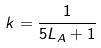<formula> <loc_0><loc_0><loc_500><loc_500>k = \frac { 1 } { 5 L _ { A } + 1 }</formula> 